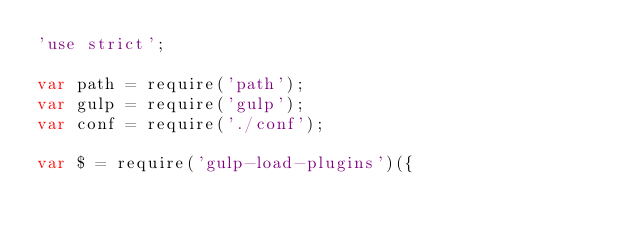Convert code to text. <code><loc_0><loc_0><loc_500><loc_500><_JavaScript_>'use strict';

var path = require('path');
var gulp = require('gulp');
var conf = require('./conf');

var $ = require('gulp-load-plugins')({</code> 